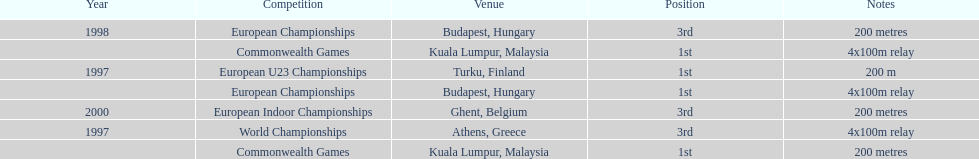What was the only event won in belgium? European Indoor Championships. Can you parse all the data within this table? {'header': ['Year', 'Competition', 'Venue', 'Position', 'Notes'], 'rows': [['1998', 'European Championships', 'Budapest, Hungary', '3rd', '200 metres'], ['', 'Commonwealth Games', 'Kuala Lumpur, Malaysia', '1st', '4x100m relay'], ['1997', 'European U23 Championships', 'Turku, Finland', '1st', '200 m'], ['', 'European Championships', 'Budapest, Hungary', '1st', '4x100m relay'], ['2000', 'European Indoor Championships', 'Ghent, Belgium', '3rd', '200 metres'], ['1997', 'World Championships', 'Athens, Greece', '3rd', '4x100m relay'], ['', 'Commonwealth Games', 'Kuala Lumpur, Malaysia', '1st', '200 metres']]} 